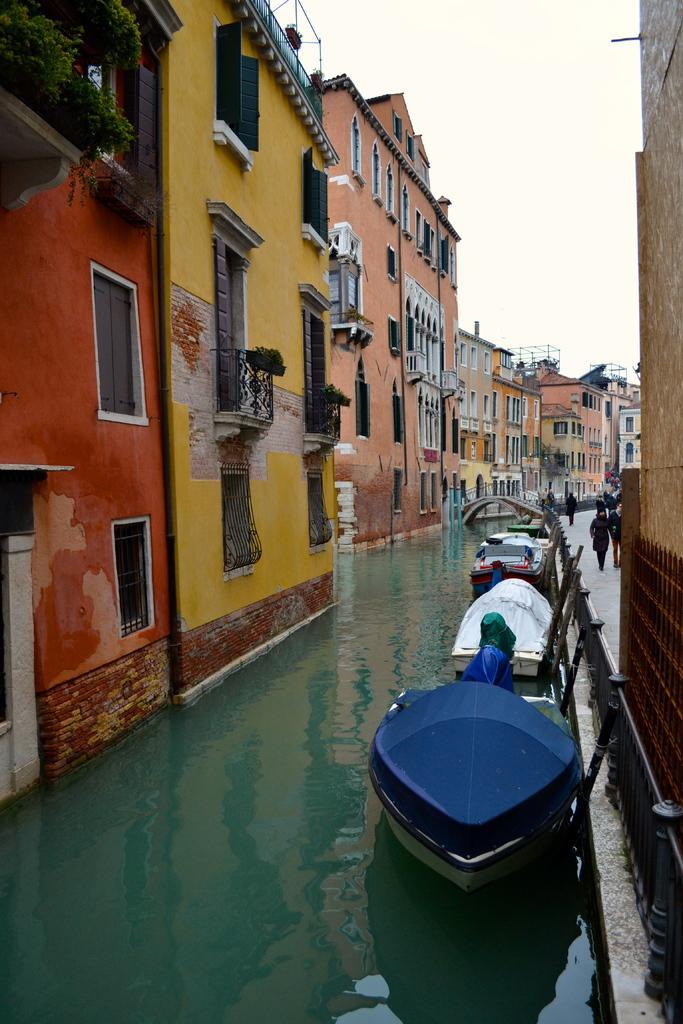Describe this image in one or two sentences. In this image I can see few boats on the water, I can also see few buildings in orange, yellow and pink color, plants in green color and the sky is in white color. 